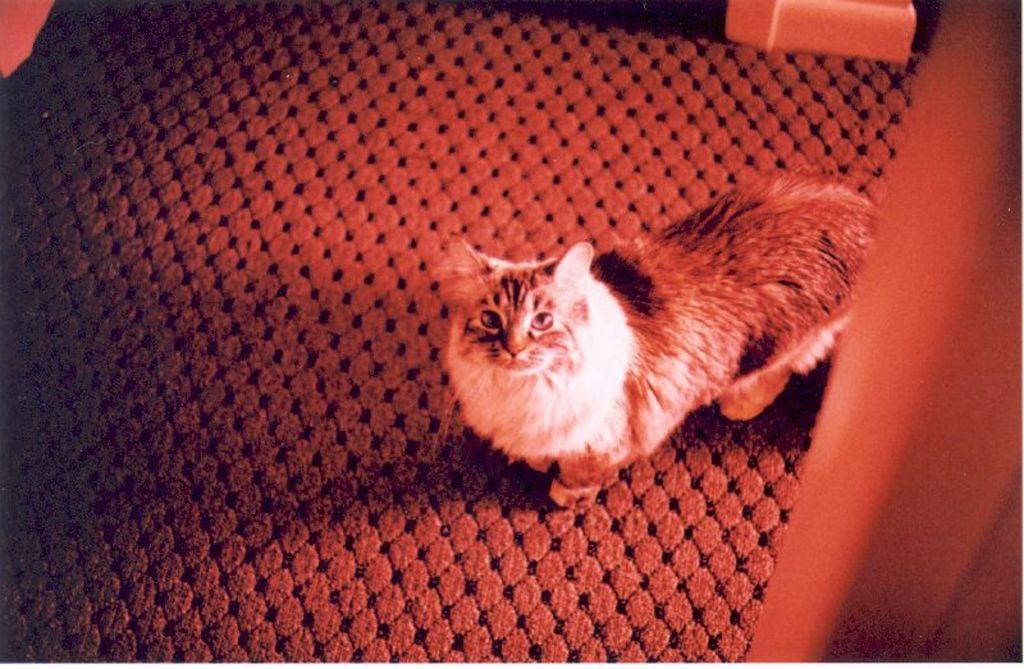What is the main subject of the image? There is a car on a mat in the image. Where is the mat located in the image? The mat is placed on the floor. What can be seen on the right side of the image? There is a wooden object on the right side of the image. What is the position of the object at the top of the image? The object at the top is also placed on the floor. What is the current status of the car's engine in the image? The image does not provide any information about the car's engine or its current status. 